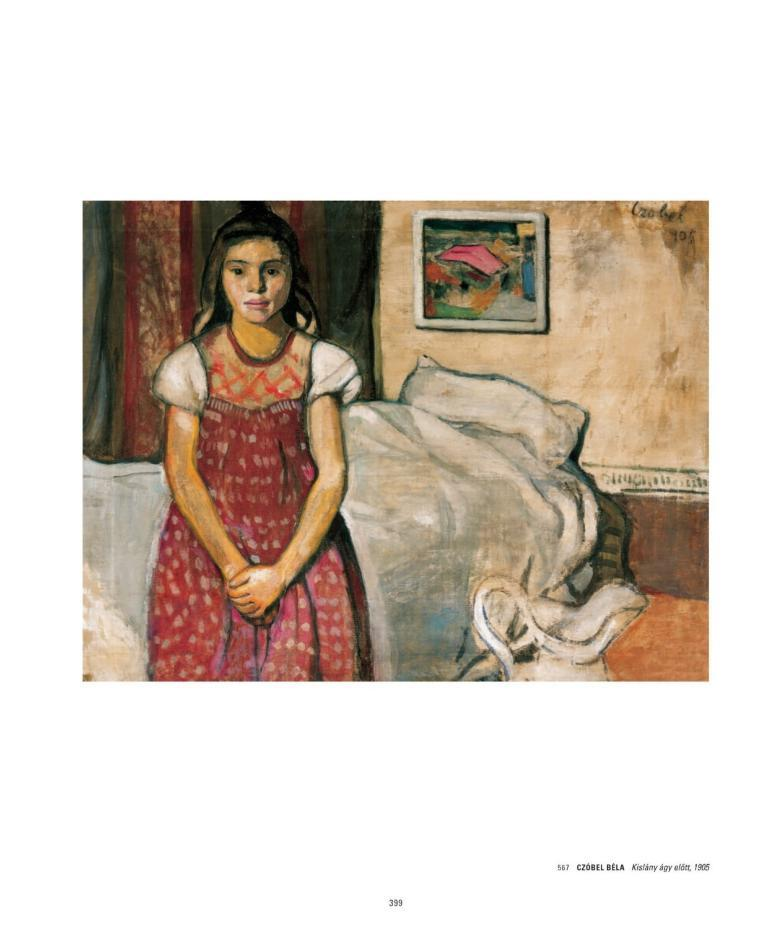What type of artwork is shown in the image? The image is a painting. Who or what is the main subject of the painting? There is a person depicted in the painting. What other elements are present in the painting? There is a wall, a photo frame, a bed, and a floor depicted in the painting. What are the person's hobbies in the painting? There is no information provided about the person's hobbies in the painting. What is the limit of the gate in the painting? There is no gate depicted in the painting. 